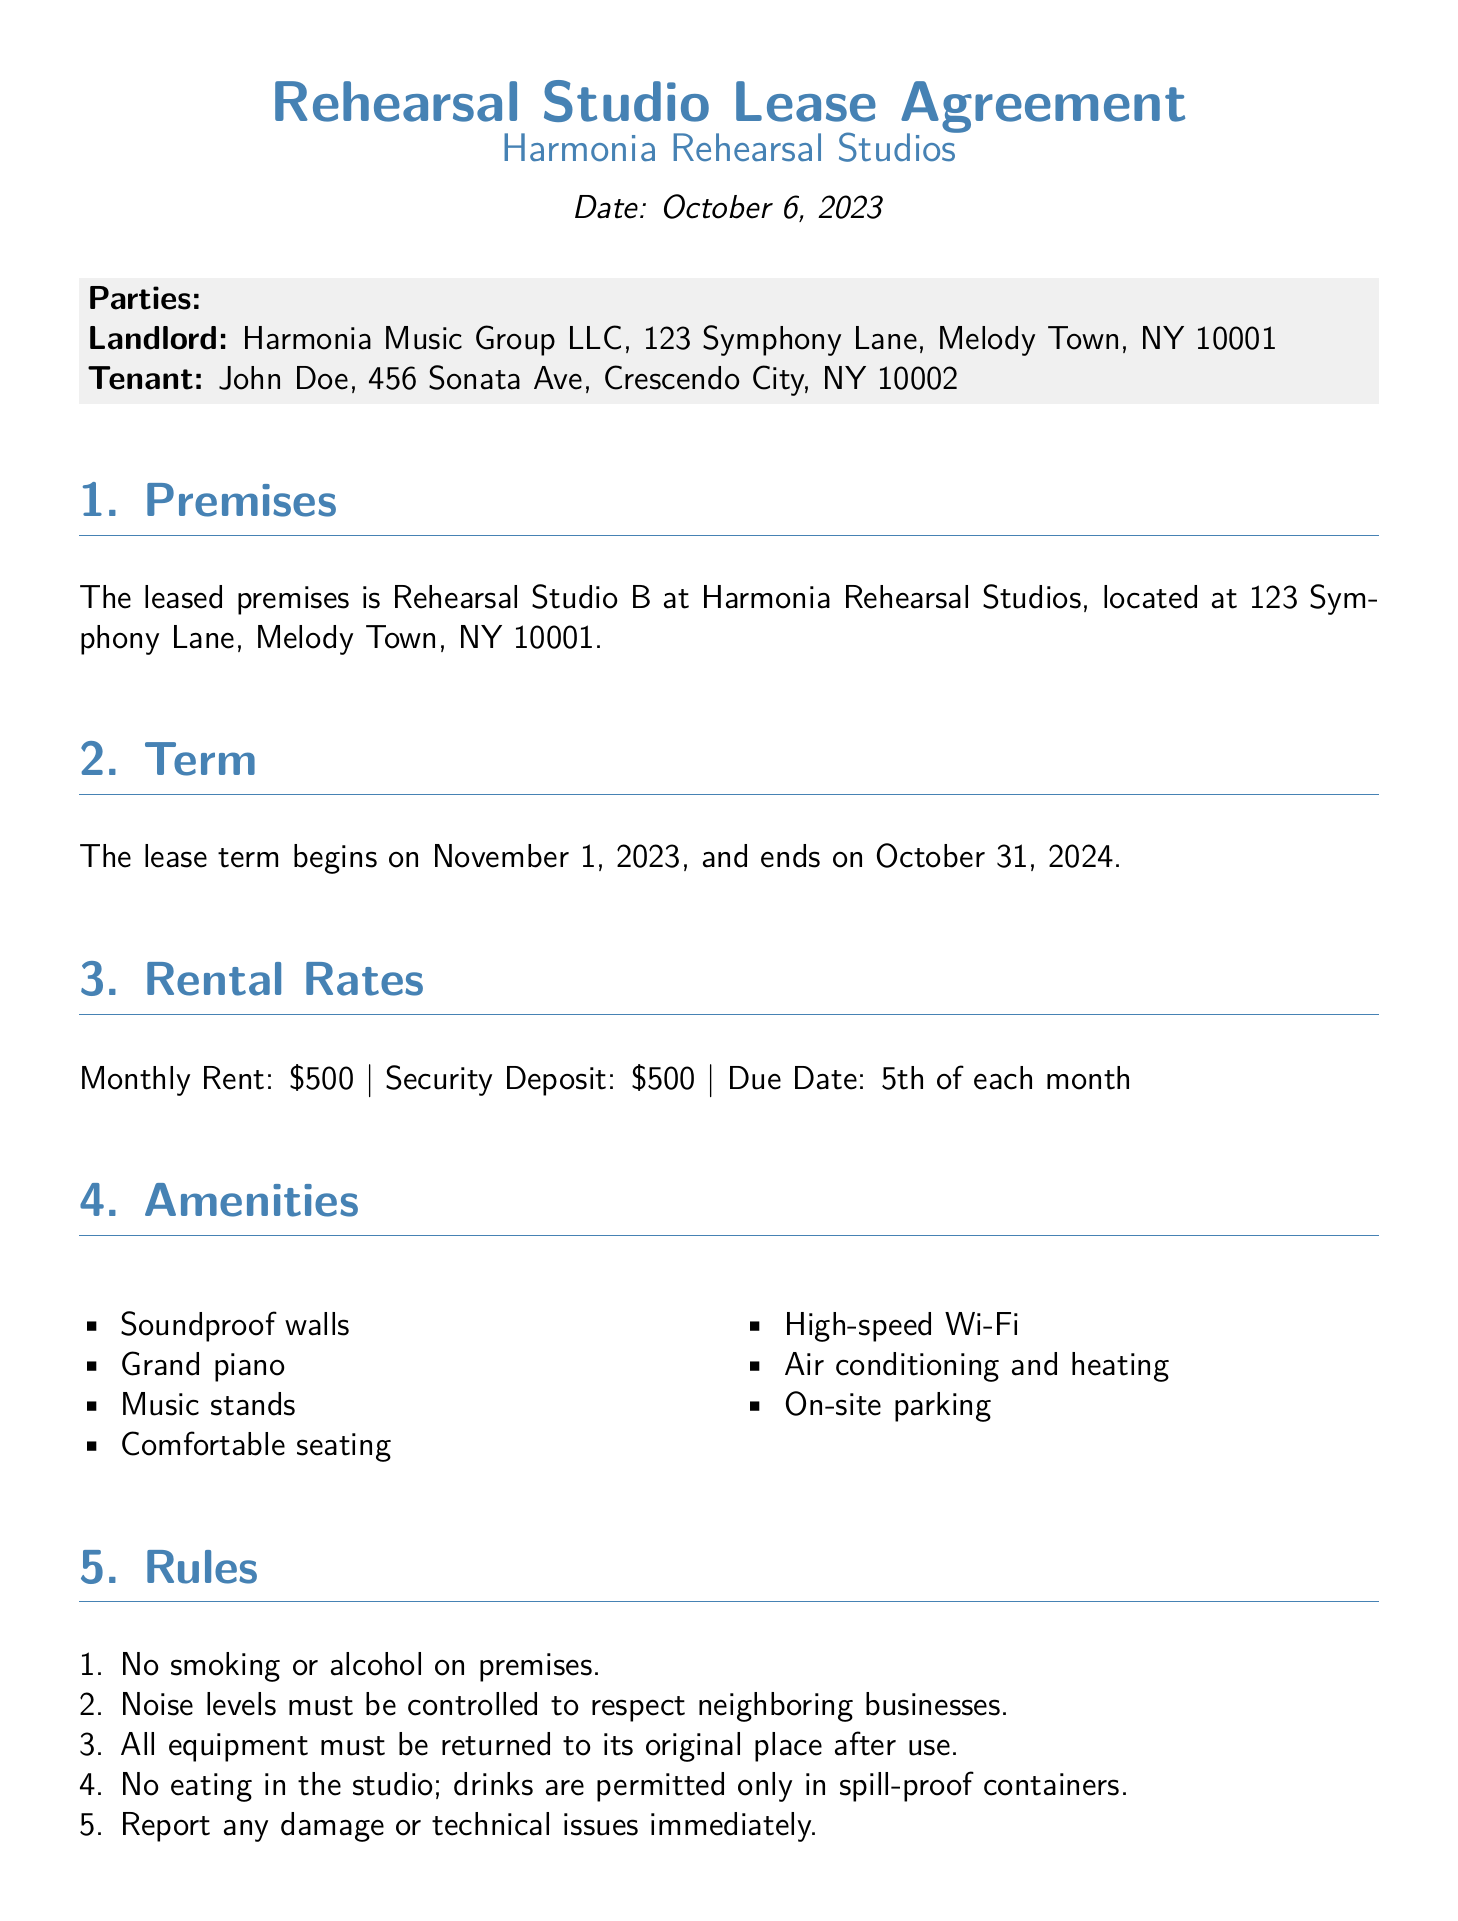What is the name of the landlord? The landlord is identified in the document as Harmonia Music Group LLC.
Answer: Harmonia Music Group LLC What is the monthly rent for the studio? The document specifies the monthly rent for the rehearsal studio is $500.
Answer: $500 When does the lease term begin? The starting date of the lease term is mentioned in the document as November 1, 2023.
Answer: November 1, 2023 What amenities are included in the studio? The document lists amenities such as soundproof walls, a grand piano, and high-speed Wi-Fi.
Answer: Soundproof walls, grand piano, high-speed Wi-Fi How much is the security deposit? The security deposit amount is stated in the lease agreement as $500.
Answer: $500 What is the notice period for termination? The document requires a 30-day written notice for termination of the lease.
Answer: 30 days Are utilities included in the rent? The document clarifies that utilities such as electricity, water, and internet are included in the rent.
Answer: Yes Is eating allowed in the studio? The rules specify that eating is not allowed in the studio.
Answer: No 